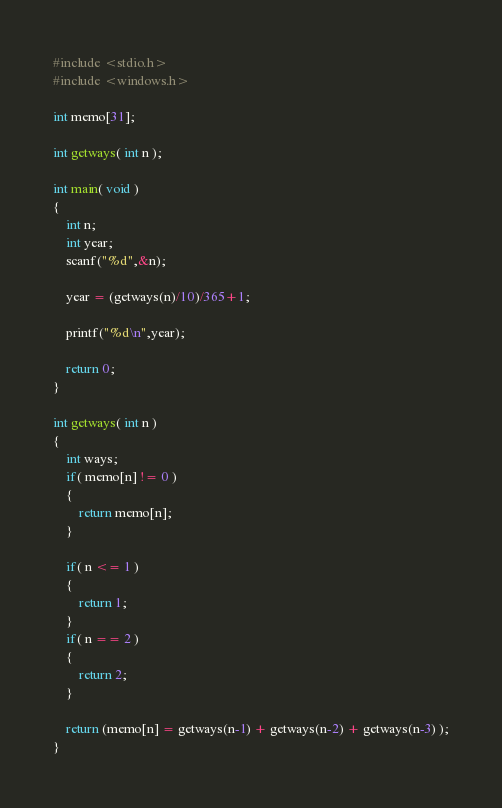Convert code to text. <code><loc_0><loc_0><loc_500><loc_500><_C_>#include <stdio.h>
#include <windows.h>

int memo[31];

int getways( int n );

int main( void )
{
	int n;
	int year;
	scanf("%d",&n);
	
	year = (getways(n)/10)/365+1;
	
	printf("%d\n",year);
	
	return 0;
}

int getways( int n )
{
	int ways;
	if( memo[n] != 0 )
	{
		return memo[n];
	}
	
	if( n <= 1 )
	{
		return 1;
	}
	if( n == 2 )
	{
		return 2;
	}
	
	return (memo[n] = getways(n-1) + getways(n-2) + getways(n-3) );
}</code> 